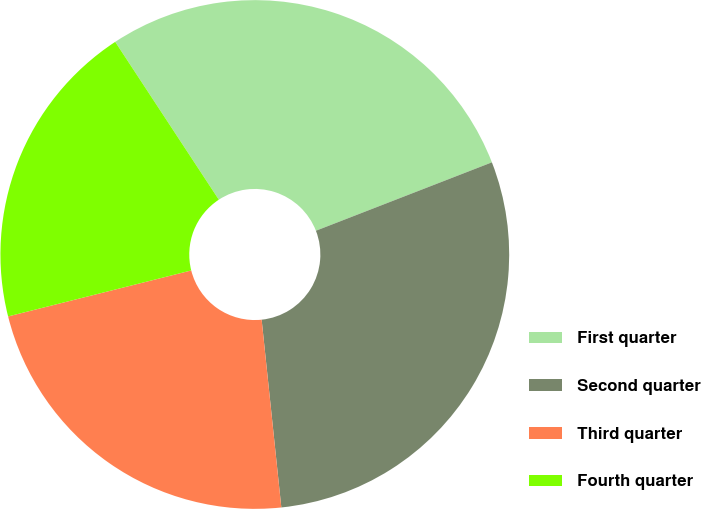Convert chart to OTSL. <chart><loc_0><loc_0><loc_500><loc_500><pie_chart><fcel>First quarter<fcel>Second quarter<fcel>Third quarter<fcel>Fourth quarter<nl><fcel>28.35%<fcel>29.24%<fcel>22.75%<fcel>19.67%<nl></chart> 